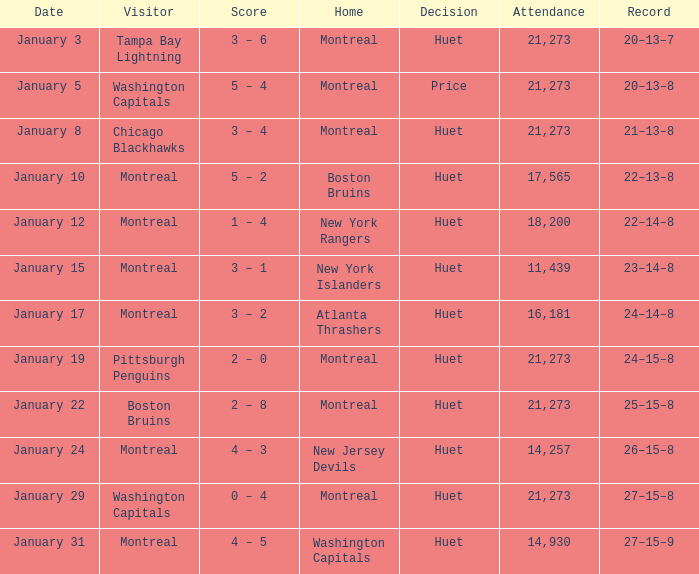What was the date of the game that had a score of 3 – 1? January 15. 